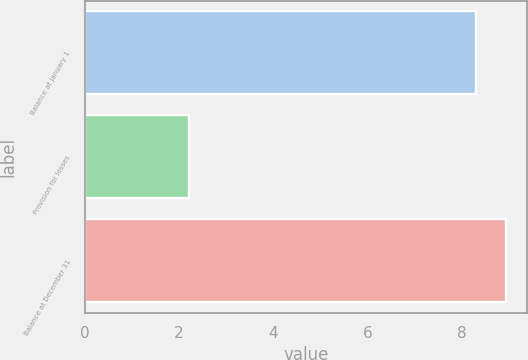<chart> <loc_0><loc_0><loc_500><loc_500><bar_chart><fcel>Balance at January 1<fcel>Provision for losses<fcel>Balance at December 31<nl><fcel>8.3<fcel>2.2<fcel>8.94<nl></chart> 